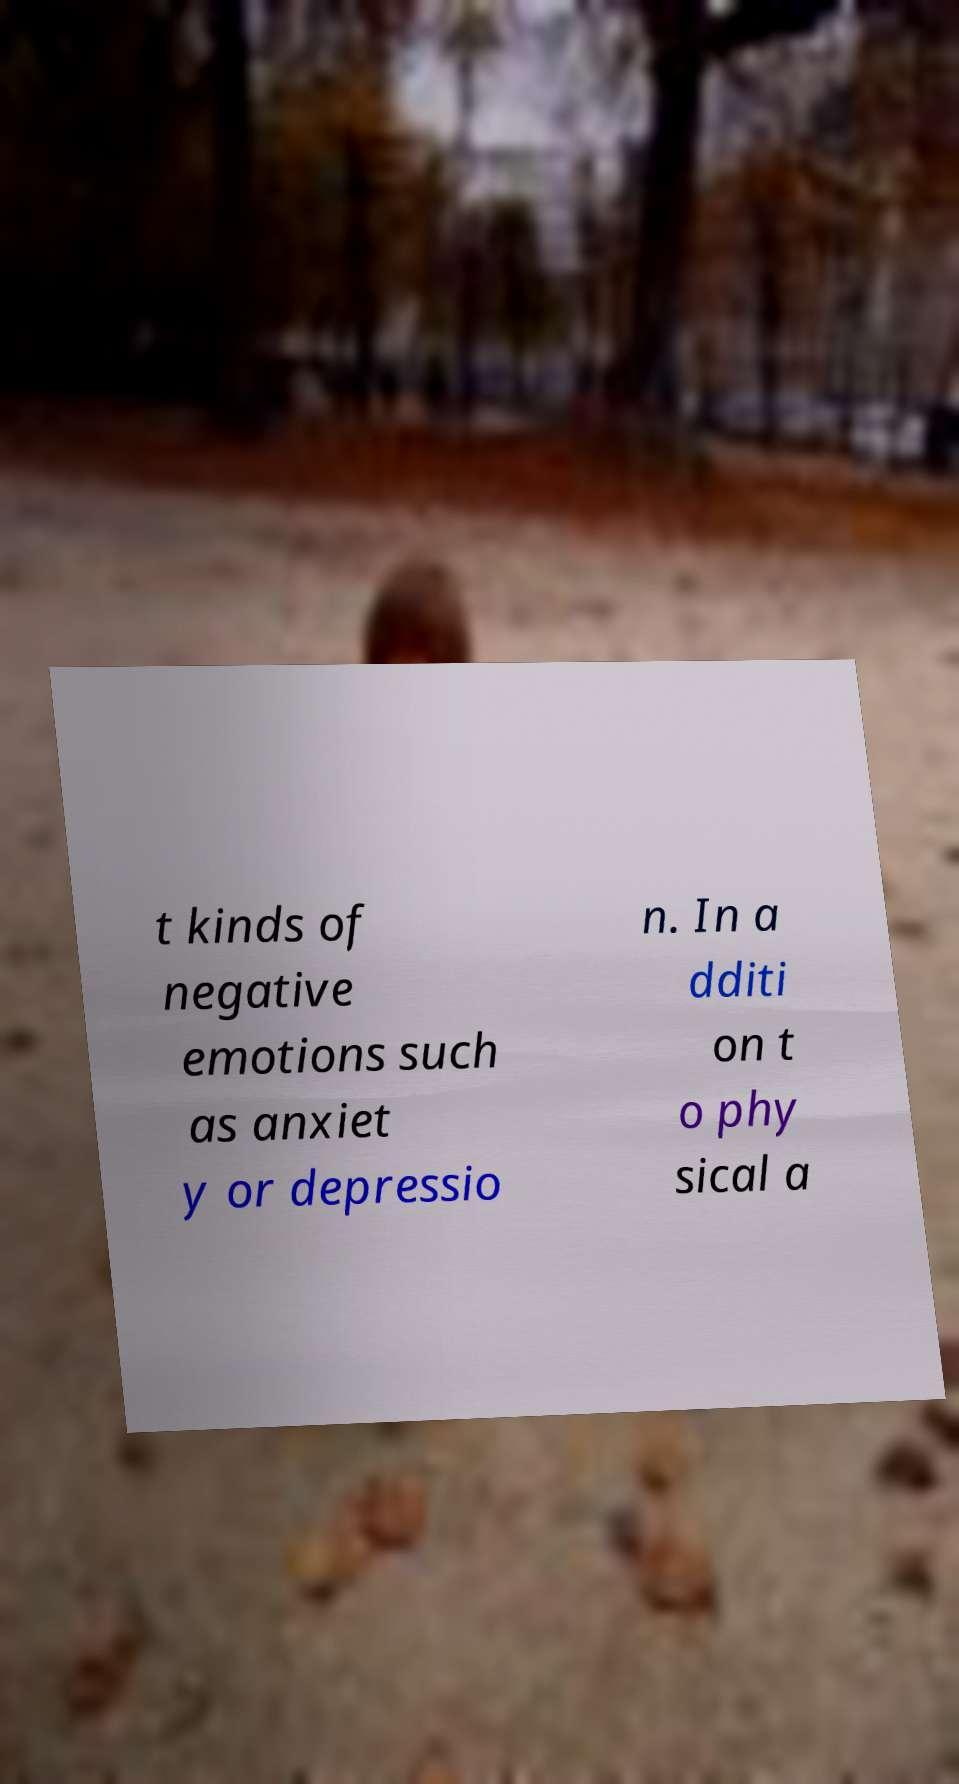What messages or text are displayed in this image? I need them in a readable, typed format. t kinds of negative emotions such as anxiet y or depressio n. In a dditi on t o phy sical a 